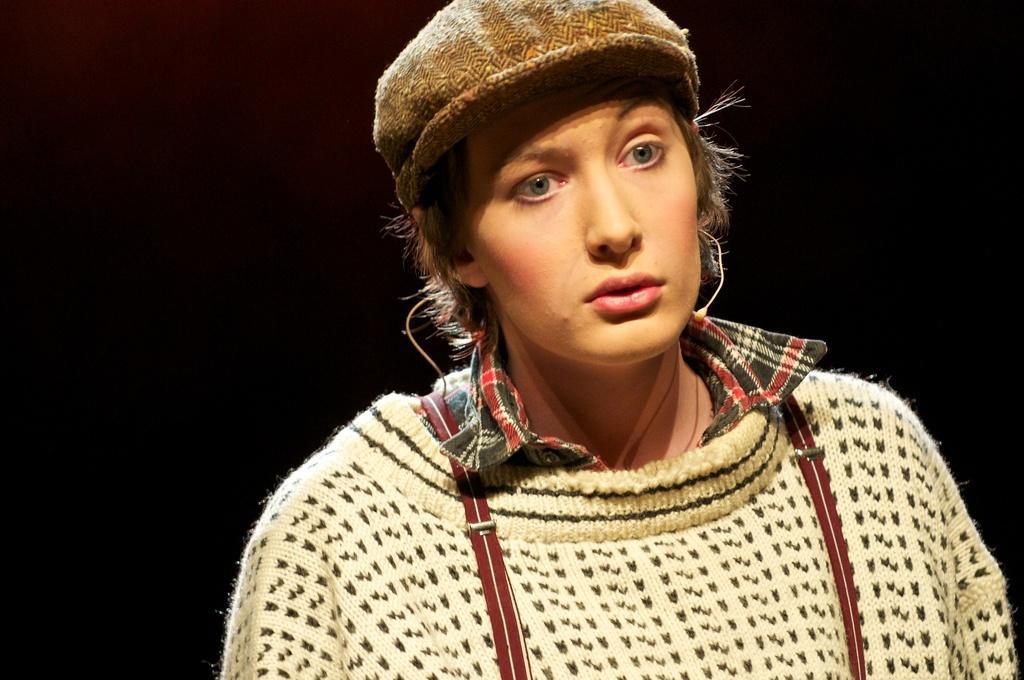How would you summarize this image in a sentence or two? In this image there is a person staring, the person is wearing a hat. 